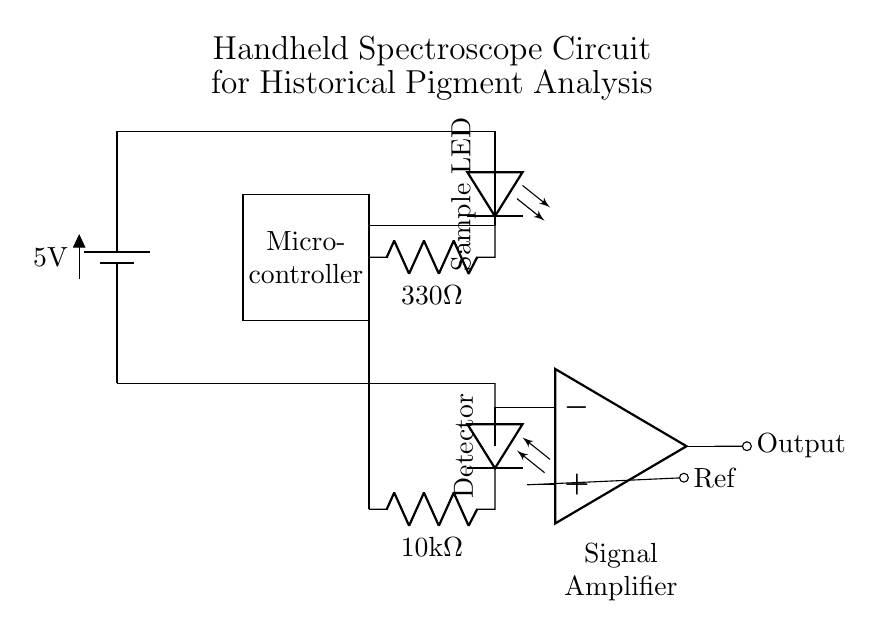What is the power supply voltage in the circuit? The power supply voltage is indicated at the battery symbol, which shows a potential difference of 5V.
Answer: 5V What type of light source is used in this circuit? The light source in the circuit is labeled as LED, which indicates that it is a light-emitting diode used for illumination.
Answer: LED What component is used to detect light in the circuit? The component used to detect light is identified as a photodiode, meaning it converts light into an electrical current.
Answer: Photodiode How many resistors are present in this circuit? There are two resistors present: one with a value of 330 Ohms and another with a value of 10 kilo-ohms, which can be counted visually on the diagram.
Answer: 2 What role does the operational amplifier play in this circuit? The operational amplifier amplifies the signal received from the photodiode, as labeled in the diagram, converting a low-level signal into a higher output signal for processing.
Answer: Signal amplifier What is the resistance value of the photodiode resistor? The resistance value of the photodiode resistor is marked in the diagram as 10 kilo-ohms, which represents the load for the photodiode in the circuit.
Answer: 10 kilo-ohms Which component interfaces with the microcontroller for processing the signal? The component that interfaces with the microcontroller is the output from the operational amplifier, as it provides the amplified signal for processing within the microcontroller.
Answer: Operational amplifier 